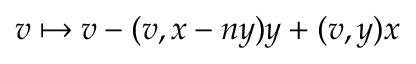<formula> <loc_0><loc_0><loc_500><loc_500>v \mapsto v - ( v , x - n y ) y + ( v , y ) x</formula> 